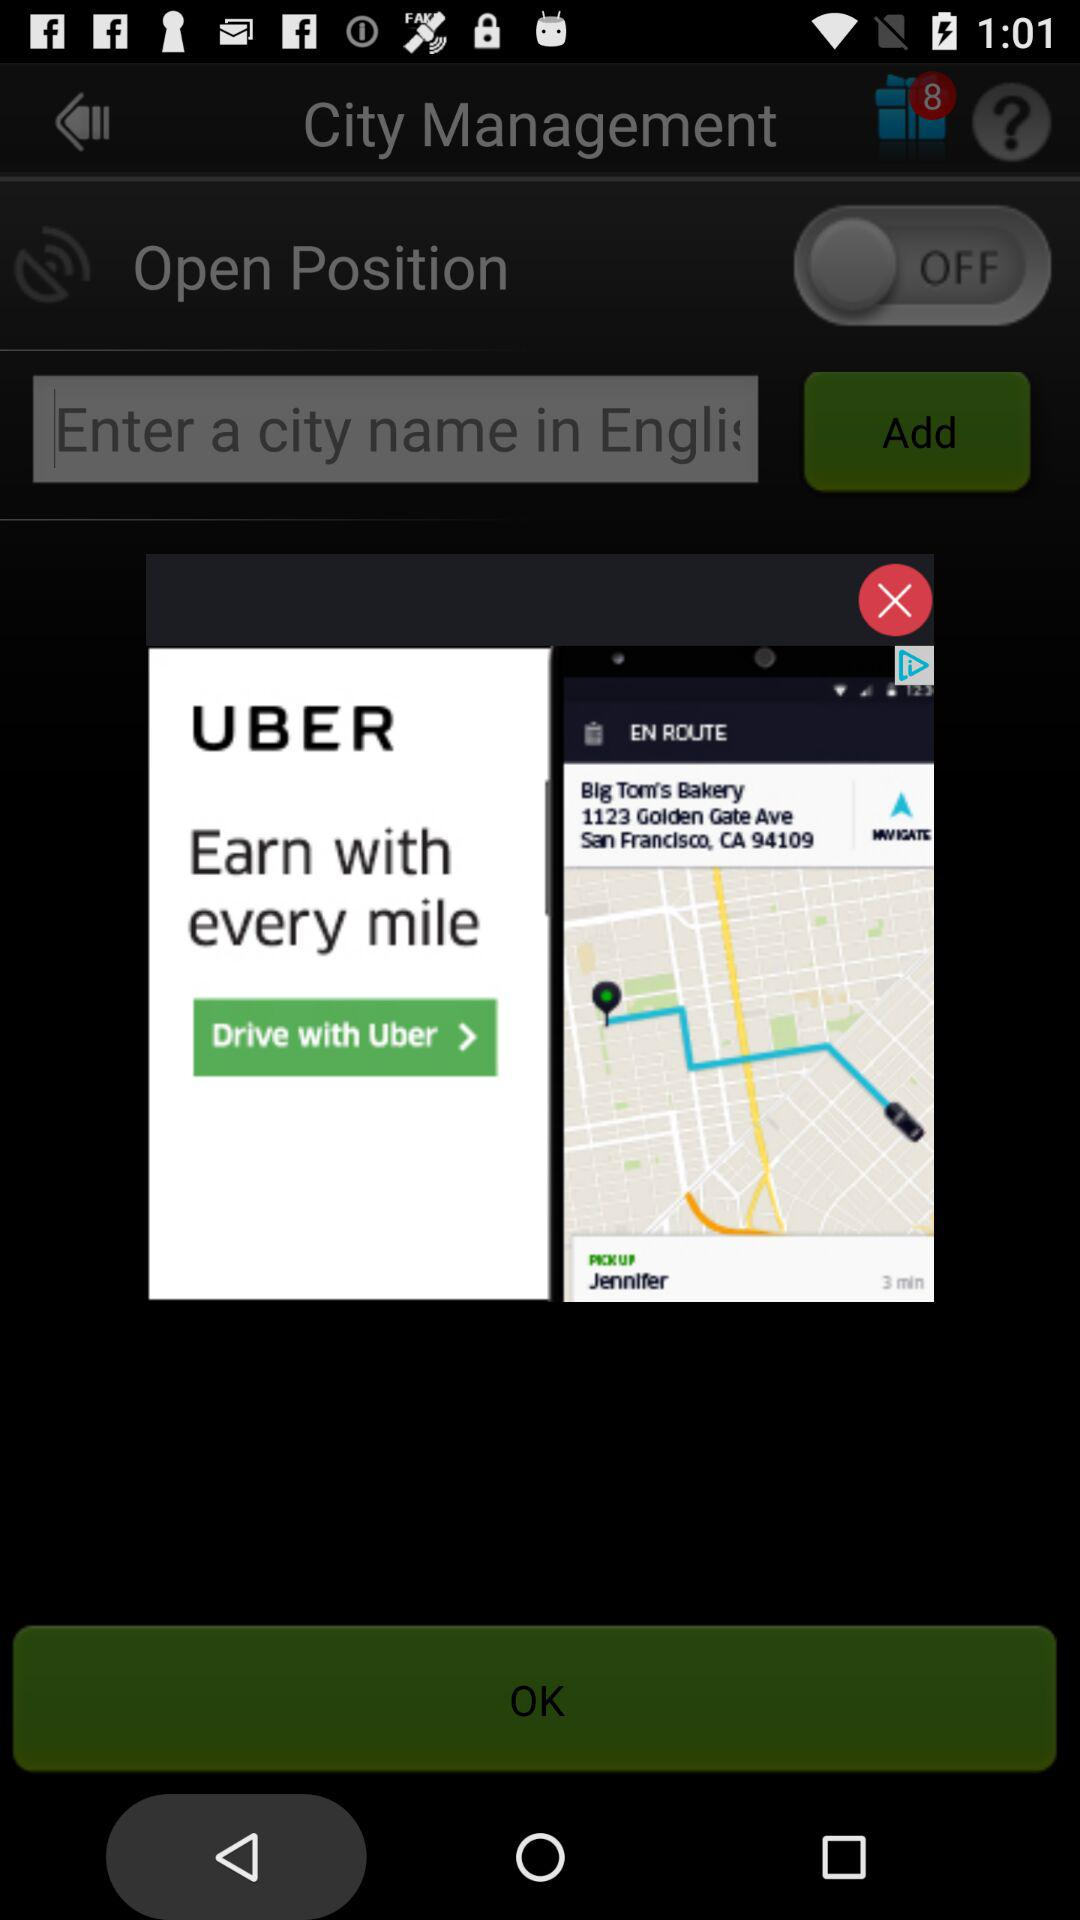What is the status of the "Open Position"? The status is "off". 